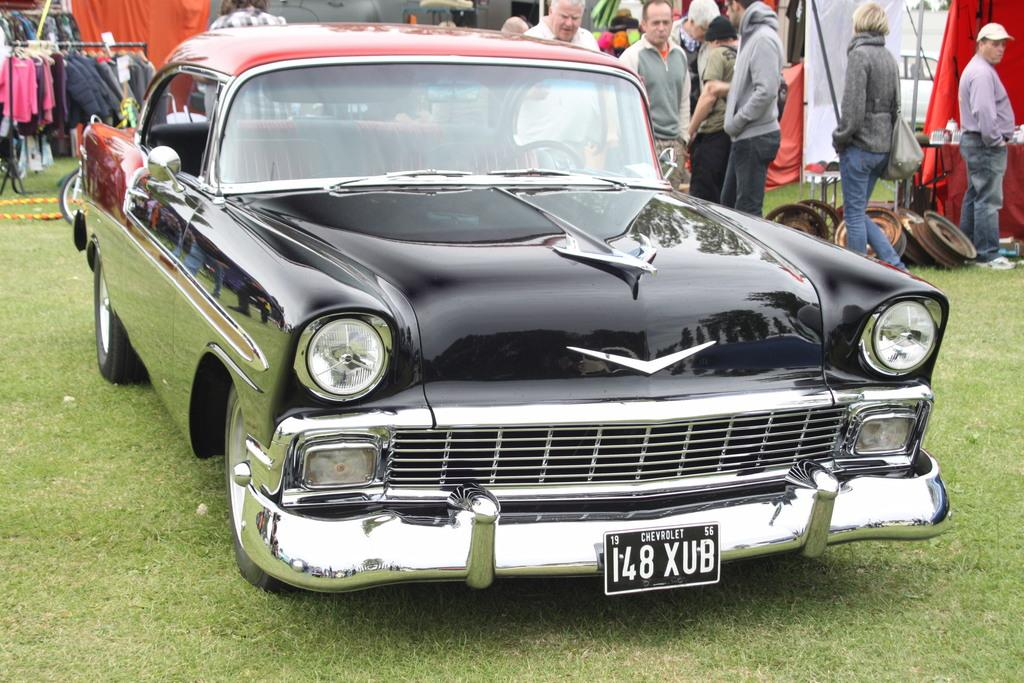What is the main subject of the image? There is a car on a grassy land in the image. What can be seen in the background of the image? A group of people is visible in the background, along with clothes and a curtain. What type of print can be seen on the car's tires in the image? There is no print visible on the car's tires in the image. How does the zephyr affect the car's movement in the image? There is no mention of a zephyr or any wind in the image, so its effect on the car's movement cannot be determined. 